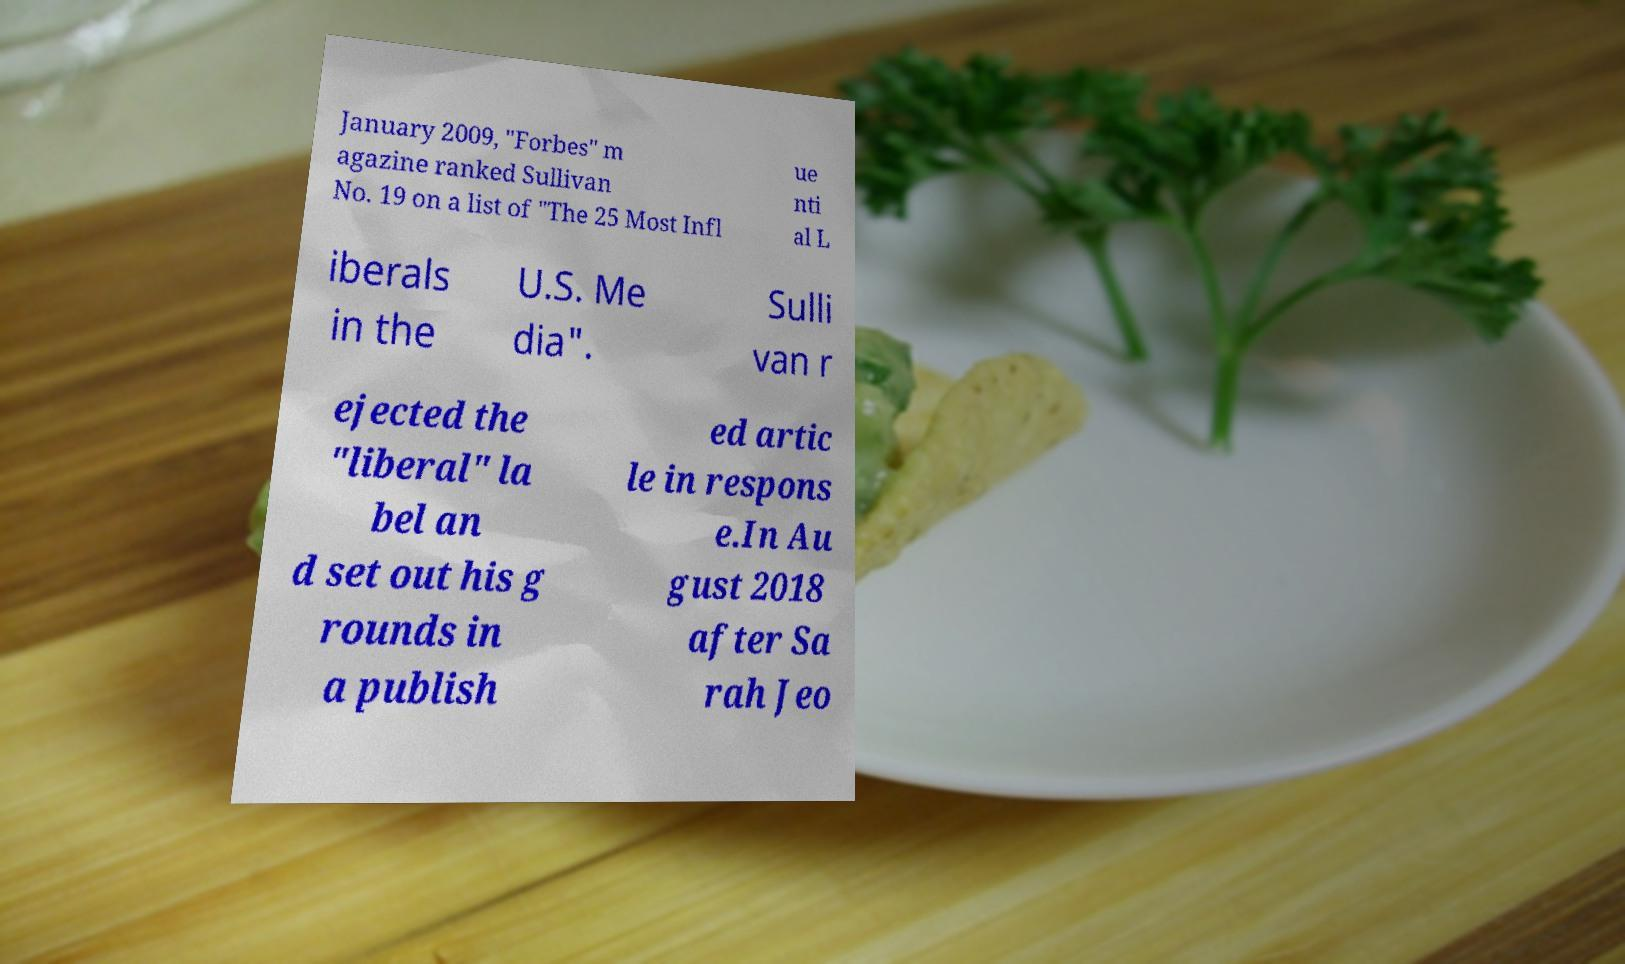I need the written content from this picture converted into text. Can you do that? January 2009, "Forbes" m agazine ranked Sullivan No. 19 on a list of "The 25 Most Infl ue nti al L iberals in the U.S. Me dia". Sulli van r ejected the "liberal" la bel an d set out his g rounds in a publish ed artic le in respons e.In Au gust 2018 after Sa rah Jeo 